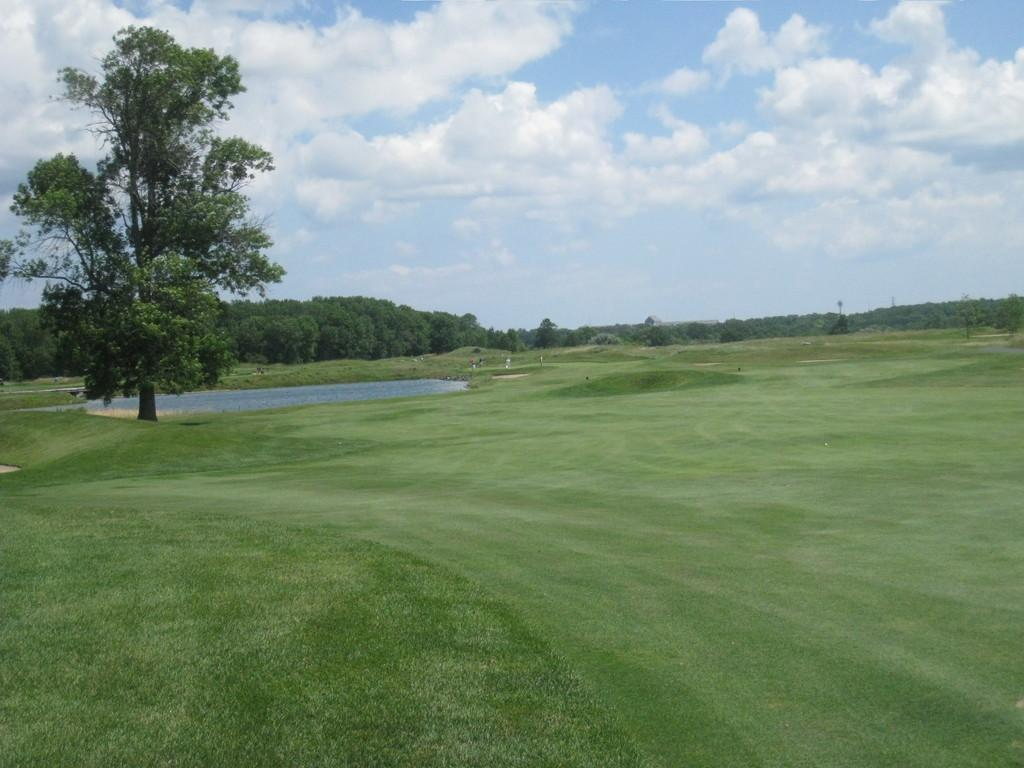What type of ground surface is visible in the image? There is grass on the ground. What body of water can be seen in the background? There is a water pond in the background. What is located near the water pond? The water pond is near a tree. What type of vegetation is visible in the background? There are trees in the background. What can be seen in the sky in the image? There are clouds in the blue sky. What type of hospital can be seen in the image? There is no hospital present in the image. Is there a house visible in the image? There is no house visible in the image. 